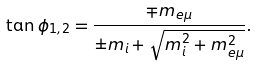<formula> <loc_0><loc_0><loc_500><loc_500>\tan \phi _ { 1 , 2 } = \frac { \mp m _ { e \mu } } { \pm m _ { i } + \sqrt { m _ { i } ^ { 2 } + m _ { e \mu } ^ { 2 } } } .</formula> 